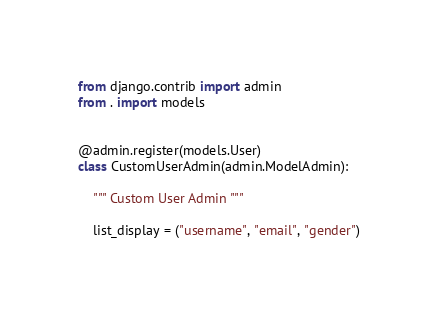Convert code to text. <code><loc_0><loc_0><loc_500><loc_500><_Python_>from django.contrib import admin
from . import models


@admin.register(models.User)
class CustomUserAdmin(admin.ModelAdmin):

    """ Custom User Admin """

    list_display = ("username", "email", "gender")
</code> 